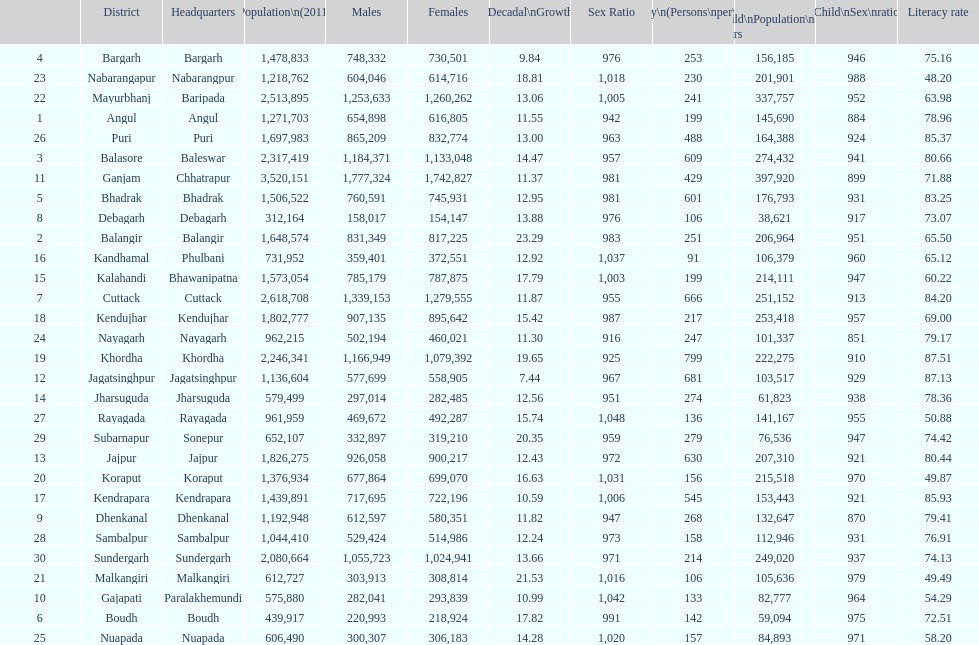Can you parse all the data within this table? {'header': ['', 'District', 'Headquarters', 'Population\\n(2011)', 'Males', 'Females', 'Percentage\\nDecadal\\nGrowth\\n2001-2011', 'Sex Ratio', 'Density\\n(Persons\\nper\\nkm2)', 'Child\\nPopulation\\n0–6 years', 'Child\\nSex\\nratio', 'Literacy rate'], 'rows': [['4', 'Bargarh', 'Bargarh', '1,478,833', '748,332', '730,501', '9.84', '976', '253', '156,185', '946', '75.16'], ['23', 'Nabarangapur', 'Nabarangpur', '1,218,762', '604,046', '614,716', '18.81', '1,018', '230', '201,901', '988', '48.20'], ['22', 'Mayurbhanj', 'Baripada', '2,513,895', '1,253,633', '1,260,262', '13.06', '1,005', '241', '337,757', '952', '63.98'], ['1', 'Angul', 'Angul', '1,271,703', '654,898', '616,805', '11.55', '942', '199', '145,690', '884', '78.96'], ['26', 'Puri', 'Puri', '1,697,983', '865,209', '832,774', '13.00', '963', '488', '164,388', '924', '85.37'], ['3', 'Balasore', 'Baleswar', '2,317,419', '1,184,371', '1,133,048', '14.47', '957', '609', '274,432', '941', '80.66'], ['11', 'Ganjam', 'Chhatrapur', '3,520,151', '1,777,324', '1,742,827', '11.37', '981', '429', '397,920', '899', '71.88'], ['5', 'Bhadrak', 'Bhadrak', '1,506,522', '760,591', '745,931', '12.95', '981', '601', '176,793', '931', '83.25'], ['8', 'Debagarh', 'Debagarh', '312,164', '158,017', '154,147', '13.88', '976', '106', '38,621', '917', '73.07'], ['2', 'Balangir', 'Balangir', '1,648,574', '831,349', '817,225', '23.29', '983', '251', '206,964', '951', '65.50'], ['16', 'Kandhamal', 'Phulbani', '731,952', '359,401', '372,551', '12.92', '1,037', '91', '106,379', '960', '65.12'], ['15', 'Kalahandi', 'Bhawanipatna', '1,573,054', '785,179', '787,875', '17.79', '1,003', '199', '214,111', '947', '60.22'], ['7', 'Cuttack', 'Cuttack', '2,618,708', '1,339,153', '1,279,555', '11.87', '955', '666', '251,152', '913', '84.20'], ['18', 'Kendujhar', 'Kendujhar', '1,802,777', '907,135', '895,642', '15.42', '987', '217', '253,418', '957', '69.00'], ['24', 'Nayagarh', 'Nayagarh', '962,215', '502,194', '460,021', '11.30', '916', '247', '101,337', '851', '79.17'], ['19', 'Khordha', 'Khordha', '2,246,341', '1,166,949', '1,079,392', '19.65', '925', '799', '222,275', '910', '87.51'], ['12', 'Jagatsinghpur', 'Jagatsinghpur', '1,136,604', '577,699', '558,905', '7.44', '967', '681', '103,517', '929', '87.13'], ['14', 'Jharsuguda', 'Jharsuguda', '579,499', '297,014', '282,485', '12.56', '951', '274', '61,823', '938', '78.36'], ['27', 'Rayagada', 'Rayagada', '961,959', '469,672', '492,287', '15.74', '1,048', '136', '141,167', '955', '50.88'], ['29', 'Subarnapur', 'Sonepur', '652,107', '332,897', '319,210', '20.35', '959', '279', '76,536', '947', '74.42'], ['13', 'Jajpur', 'Jajpur', '1,826,275', '926,058', '900,217', '12.43', '972', '630', '207,310', '921', '80.44'], ['20', 'Koraput', 'Koraput', '1,376,934', '677,864', '699,070', '16.63', '1,031', '156', '215,518', '970', '49.87'], ['17', 'Kendrapara', 'Kendrapara', '1,439,891', '717,695', '722,196', '10.59', '1,006', '545', '153,443', '921', '85.93'], ['9', 'Dhenkanal', 'Dhenkanal', '1,192,948', '612,597', '580,351', '11.82', '947', '268', '132,647', '870', '79.41'], ['28', 'Sambalpur', 'Sambalpur', '1,044,410', '529,424', '514,986', '12.24', '973', '158', '112,946', '931', '76.91'], ['30', 'Sundergarh', 'Sundergarh', '2,080,664', '1,055,723', '1,024,941', '13.66', '971', '214', '249,020', '937', '74.13'], ['21', 'Malkangiri', 'Malkangiri', '612,727', '303,913', '308,814', '21.53', '1,016', '106', '105,636', '979', '49.49'], ['10', 'Gajapati', 'Paralakhemundi', '575,880', '282,041', '293,839', '10.99', '1,042', '133', '82,777', '964', '54.29'], ['6', 'Boudh', 'Boudh', '439,917', '220,993', '218,924', '17.82', '991', '142', '59,094', '975', '72.51'], ['25', 'Nuapada', 'Nuapada', '606,490', '300,307', '306,183', '14.28', '1,020', '157', '84,893', '971', '58.20']]} What is the number of districts with percentage decadal growth above 15% 10. 